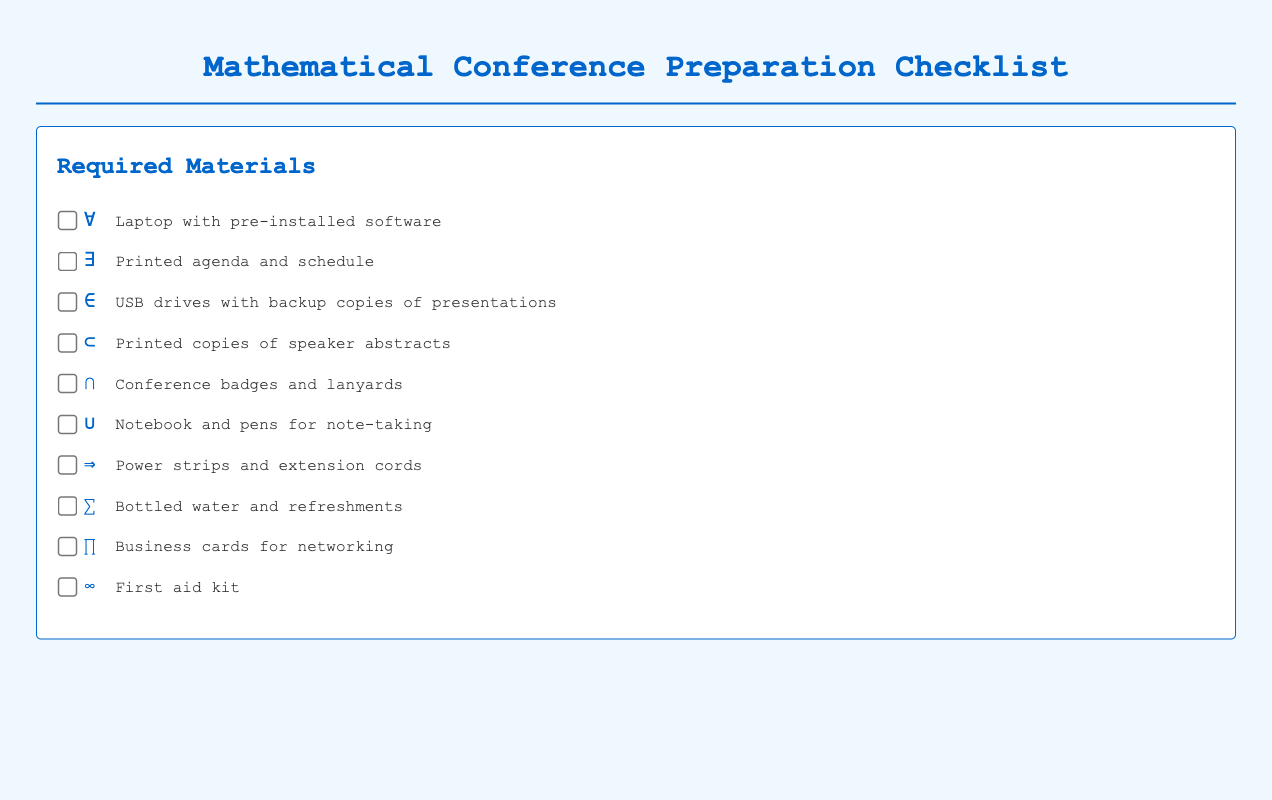What is the first item listed in the Required Materials? The first item is the laptop with pre-installed software, as listed at the top of the materials checklist.
Answer: Laptop with pre-installed software How many items are in the Required Materials checklist? There are ten items listed under the Required Materials section of the document.
Answer: Ten What symbol is associated with printed agenda and schedule? The symbol for printed agenda and schedule is the existential quantifier symbol, which is represented by "∃".
Answer: ∃ What type of document is this? The document is a checklist specifically designed for preparing for a mathematical conference, detailing materials needed and other preparation details.
Answer: Checklist What is the last item mentioned in the checklist? The last item in the checklist is the first aid kit, which is required for safety during the conference.
Answer: First aid kit How should a checked item appear in the checklist? When an item is checked, it will have a line through it and the text color changes to a lighter shade to indicate completion.
Answer: Line-through and lighter color What is recommended for note-taking? The checklist suggests bringing a notebook and pens specifically for the purpose of note-taking during the conference.
Answer: Notebook and pens What item is associated with networking? Business cards are mentioned in the checklist as a necessary item for networking opportunities during the conference.
Answer: Business cards What is needed for power access? The checklist highlights the need for power strips and extension cords to ensure access to electricity for devices.
Answer: Power strips and extension cords 